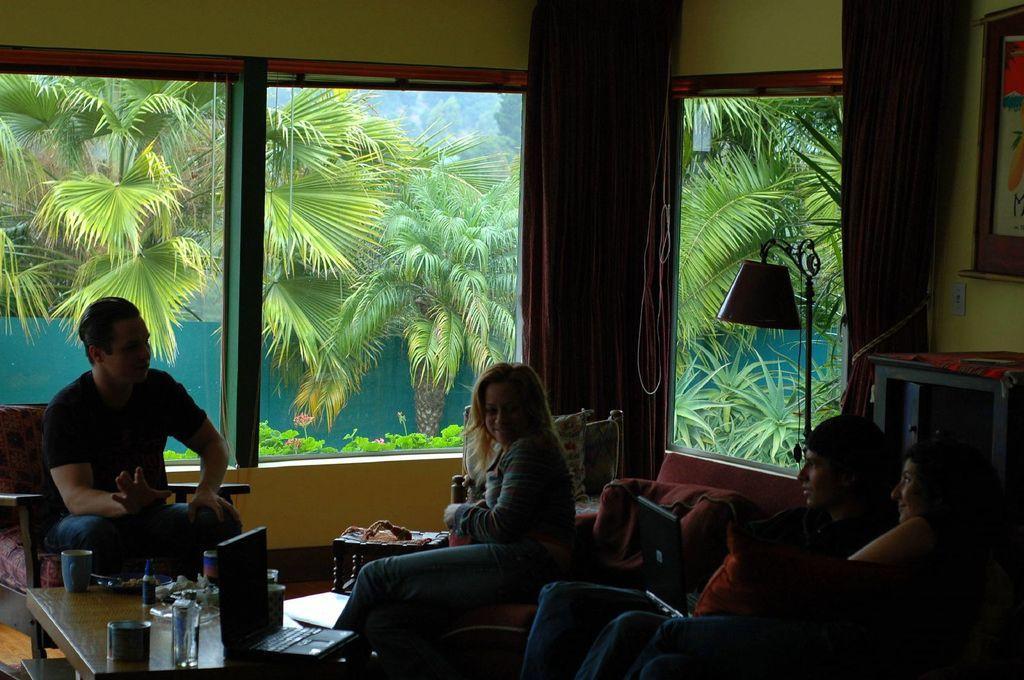How would you summarize this image in a sentence or two? In this image we have a couple of people who are sitting on the chair and talking to each other. Here we have a table with a laptop and few other objects on it. Here we have the trees and plants. 